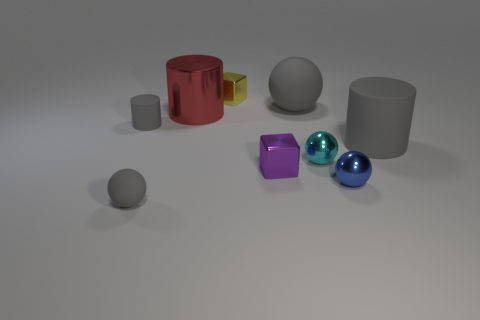There is a big thing that is the same color as the large sphere; what shape is it?
Provide a short and direct response. Cylinder. Are there any other things of the same color as the big ball?
Offer a terse response. Yes. What number of other objects are there of the same material as the purple block?
Offer a very short reply. 4. The yellow object has what size?
Give a very brief answer. Small. Is there a small gray rubber object of the same shape as the tiny cyan thing?
Make the answer very short. Yes. What number of objects are yellow cylinders or gray cylinders on the right side of the tiny cyan sphere?
Keep it short and to the point. 1. What color is the rubber cylinder that is to the left of the tiny yellow object?
Offer a terse response. Gray. There is a gray sphere behind the tiny blue object; is it the same size as the gray matte cylinder that is to the right of the small purple metal thing?
Provide a short and direct response. Yes. Is there another purple object that has the same size as the purple metal thing?
Keep it short and to the point. No. How many objects are to the left of the gray rubber ball in front of the purple shiny object?
Keep it short and to the point. 1. 